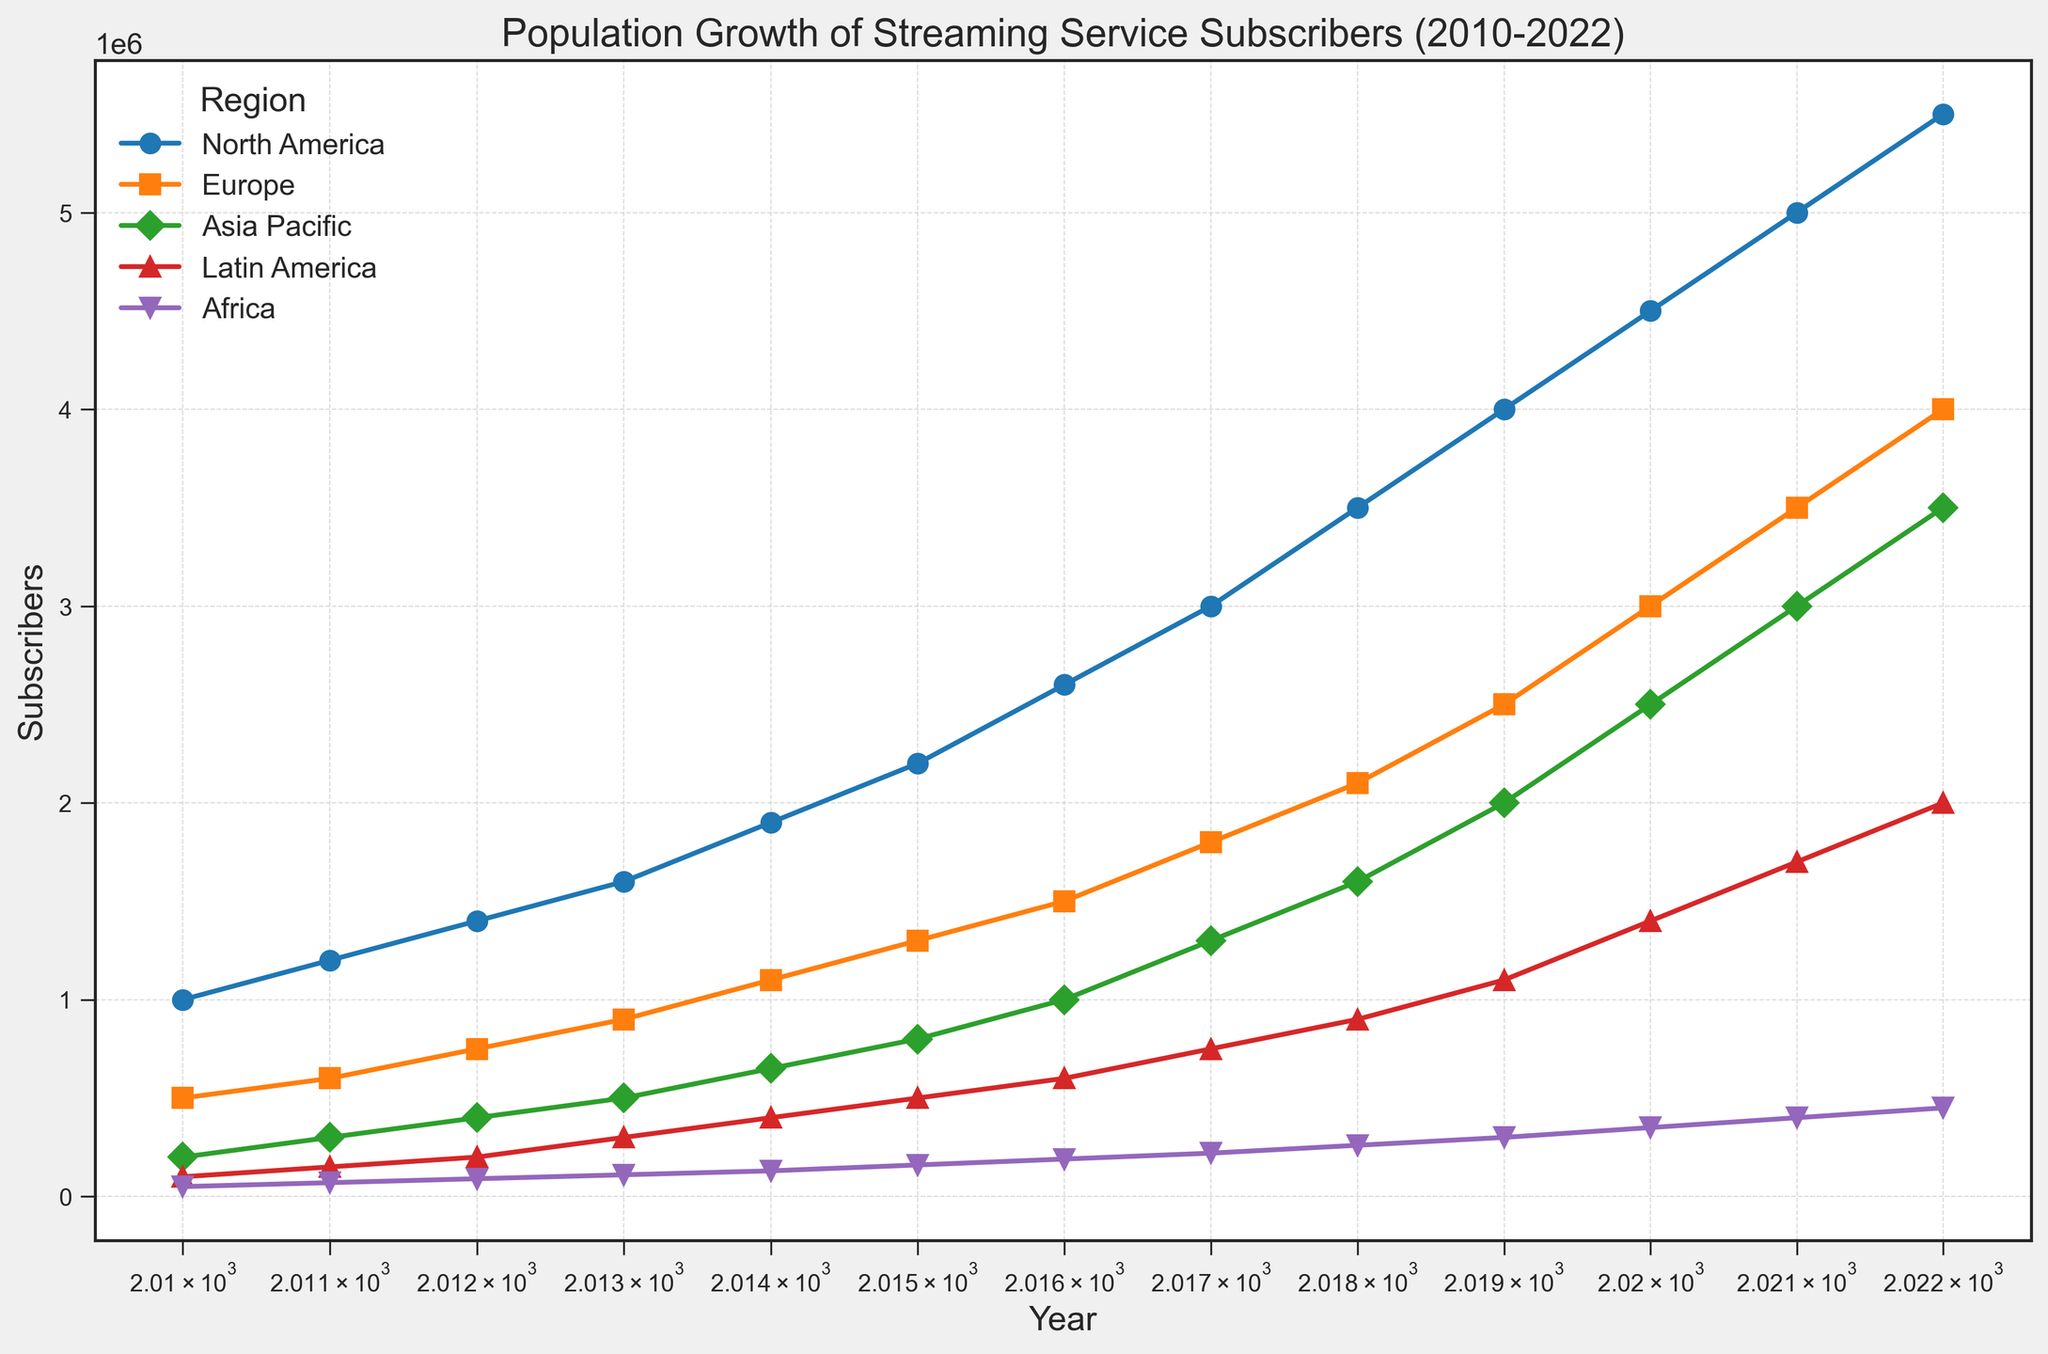What's the trend in subscriber growth for North America from 2010 to 2022? The subscriber count in North America starts at 1,000,000 in 2010 and increases each year, reaching 5,500,000 in 2022. This indicates a consistently increasing trend.
Answer: Consistently increasing trend Which region had the highest subscriber growth in 2022? By comparing the subscriber counts across regions in 2022, North America leads with 5,500,000 subscribers followed by Europe and Asia Pacific.
Answer: North America What's the difference in subscribers between Europe and Asia Pacific in 2020? In 2020, Europe has 3,000,000 subscribers and Asia Pacific has 2,500,000 subscribers. The difference is 3,000,000 - 2,500,000 = 500,000.
Answer: 500,000 How did the subscriber count in Africa change from 2010 to 2022? In 2010, Africa had 50,000 subscribers, and by 2022, the number increased to 450,000. The change is 450,000 - 50,000 = 400,000.
Answer: Increased by 400,000 Rank the regions by the number of subscribers in 2015 from highest to lowest. In 2015, the subscriber counts are: North America (2,200,000), Europe (1,300,000), Asia Pacific (800,000), Latin America (500,000), and Africa (160,000). So, the ranking is North America, Europe, Asia Pacific, Latin America, Africa.
Answer: North America > Europe > Asia Pacific > Latin America > Africa What can you say about the subscriber growth rate in Latin America between 2010 and 2022? Latin America's subscribers grow from 100,000 in 2010 to 2,000,000 in 2022. The overall growth indicates a significant upward trend in subscribers over the years.
Answer: Significant upward trend Compare the subscriber growth rate between 2017 and 2018 for Asia Pacific and North America. Between 2017 and 2018, Asia Pacific grows from 1,300,000 to 1,600,000, an increase of 300,000, which is about 23%. North America grows from 3,000,000 to 3,500,000, an increase of 500,000, which is about 16.7%.
Answer: Asia Pacific > North America What are the key visual indicators that help identify the region with the highest subscriber count? The key visual indicators are the markers and colors used to distinguish regions. North America is marked with a blue 'o', and its data line is the highest on the chart, indicating the highest subscriber count.
Answer: Blue 'o' marker with the highest data line (North America) Which region had the smallest subscriber base throughout the years and what is the trend? Africa consistently shows the smallest subscriber count throughout the years, starting from 50,000 in 2010 and growing to 450,000 in 2022. The trend is upward but remains the smallest among the regions.
Answer: Africa, upward trend If you were to compare the average subscriber count for Europe and Asia Pacific from 2010 to 2022, what can you infer? For Europe, sum of subscribers from 2010 to 2022 is 39,250,000 / 13 = 3,019,230. For Asia Pacific, sum of subscribers from 2010 to 2022 is 20,450,000 / 13 = 1,573,076. Europe has a higher average subscriber count.
Answer: Europe has a higher average 